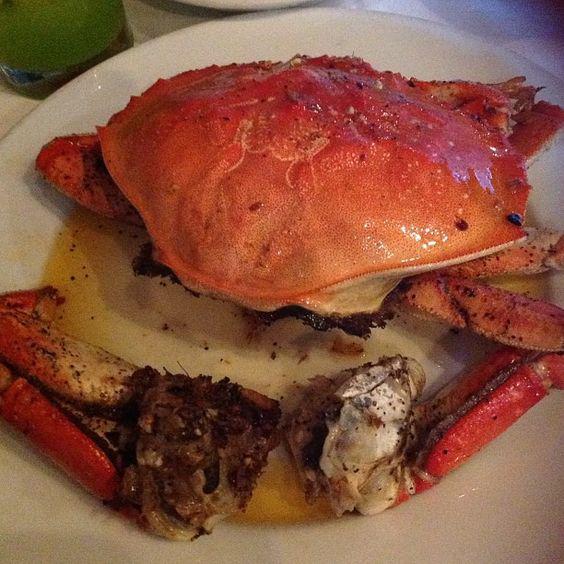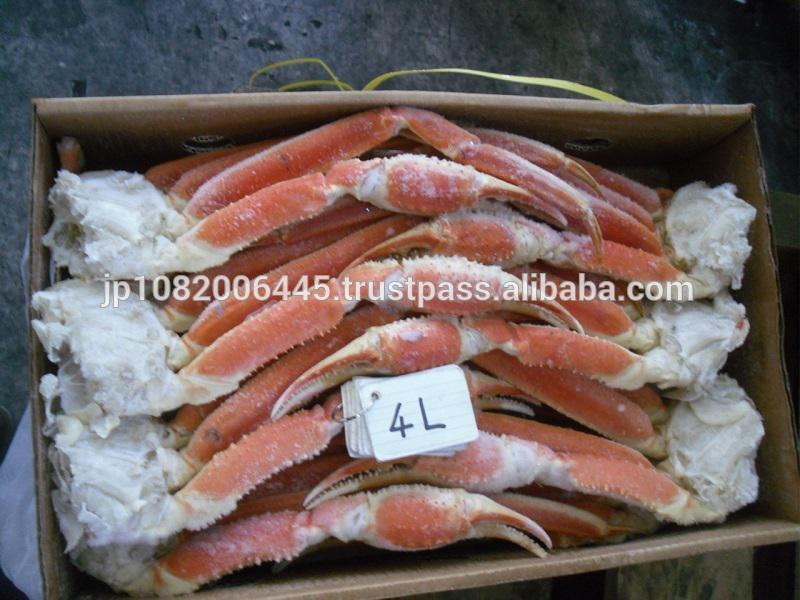The first image is the image on the left, the second image is the image on the right. Analyze the images presented: Is the assertion "There are two crabs" valid? Answer yes or no. No. 